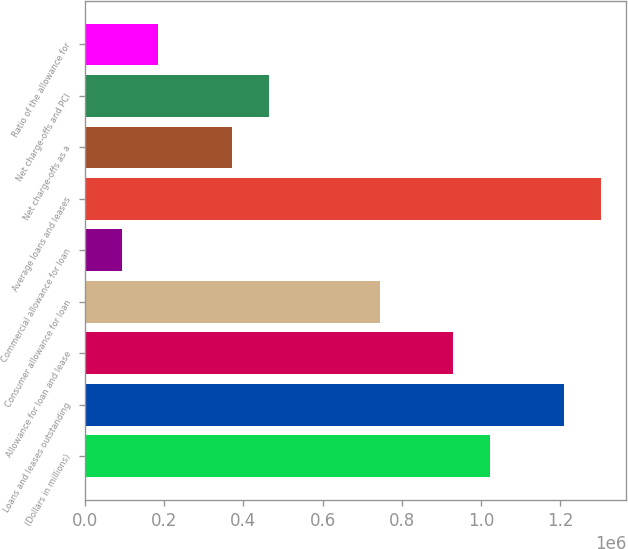Convert chart to OTSL. <chart><loc_0><loc_0><loc_500><loc_500><bar_chart><fcel>(Dollars in millions)<fcel>Loans and leases outstanding<fcel>Allowance for loan and lease<fcel>Consumer allowance for loan<fcel>Commercial allowance for loan<fcel>Average loans and leases<fcel>Net charge-offs as a<fcel>Net charge-offs and PCI<fcel>Ratio of the allowance for<nl><fcel>1.02263e+06<fcel>1.20856e+06<fcel>929661<fcel>743729<fcel>92967.2<fcel>1.30152e+06<fcel>371865<fcel>464831<fcel>185933<nl></chart> 